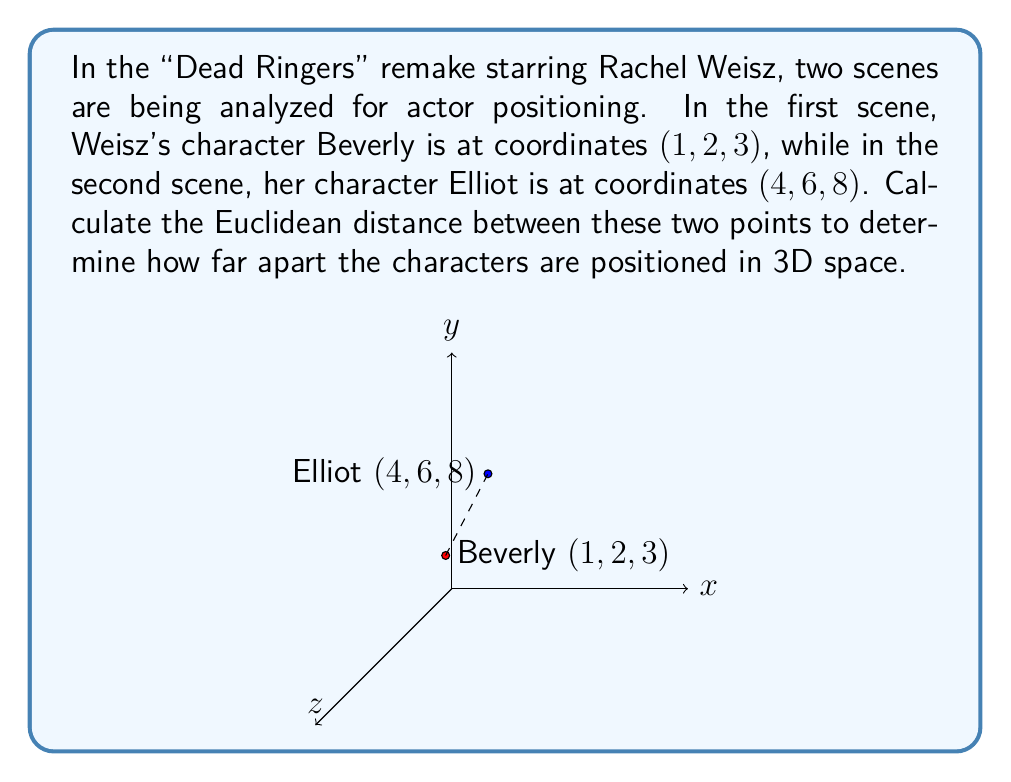Give your solution to this math problem. To calculate the Euclidean distance between two points in 3D space, we use the formula:

$$d = \sqrt{(x_2 - x_1)^2 + (y_2 - y_1)^2 + (z_2 - z_1)^2}$$

Where $(x_1, y_1, z_1)$ are the coordinates of the first point and $(x_2, y_2, z_2)$ are the coordinates of the second point.

Let's plug in our values:
- Beverly's position: $(x_1, y_1, z_1) = (1, 2, 3)$
- Elliot's position: $(x_2, y_2, z_2) = (4, 6, 8)$

Now, let's calculate step by step:

1) First, calculate the differences:
   $x_2 - x_1 = 4 - 1 = 3$
   $y_2 - y_1 = 6 - 2 = 4$
   $z_2 - z_1 = 8 - 3 = 5$

2) Square each difference:
   $(x_2 - x_1)^2 = 3^2 = 9$
   $(y_2 - y_1)^2 = 4^2 = 16$
   $(z_2 - z_1)^2 = 5^2 = 25$

3) Sum the squared differences:
   $9 + 16 + 25 = 50$

4) Take the square root of the sum:
   $d = \sqrt{50}$

5) Simplify:
   $d = 5\sqrt{2}$

Therefore, the Euclidean distance between Beverly's position and Elliot's position is $5\sqrt{2}$ units.
Answer: $5\sqrt{2}$ units 